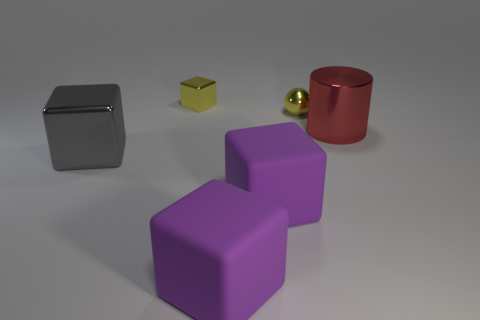Subtract all blue cubes. Subtract all blue cylinders. How many cubes are left? 4 Add 1 green things. How many objects exist? 7 Subtract all cylinders. How many objects are left? 5 Subtract 0 purple balls. How many objects are left? 6 Subtract all tiny yellow things. Subtract all large gray objects. How many objects are left? 3 Add 3 yellow metal things. How many yellow metal things are left? 5 Add 1 large cyan cubes. How many large cyan cubes exist? 1 